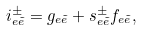<formula> <loc_0><loc_0><loc_500><loc_500>i _ { e \tilde { e } } ^ { \pm } = g _ { e \tilde { e } } + s _ { e \tilde { e } } ^ { \pm } f _ { e \tilde { e } } ,</formula> 